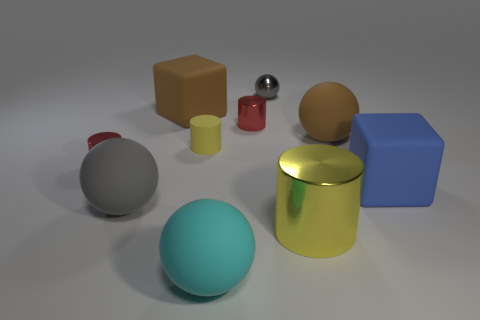What materials are the objects made of? The objects depicted seem to have varying materials. For instance, we have a matte finish on the tiny cylinder and the cube, a shiny metallic look on the small sphere, and the remaining objects exhibit reflective surfaces indicative of either polished metal or smooth plastic. 